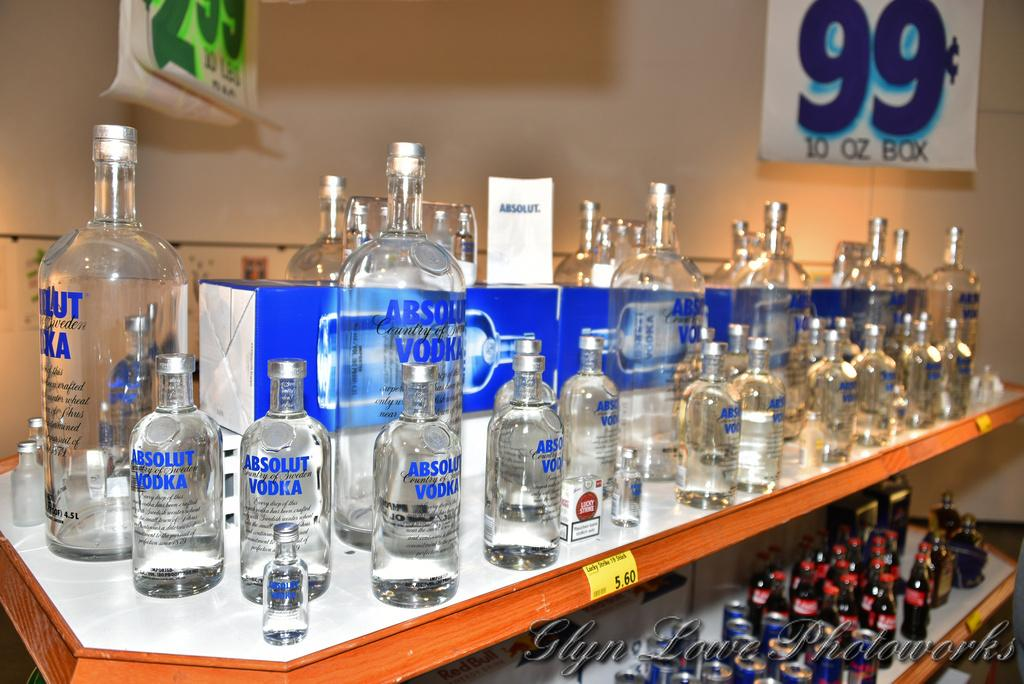<image>
Present a compact description of the photo's key features. A display with several liqour bottle of Absolue Vodka. 